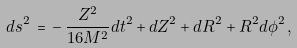Convert formula to latex. <formula><loc_0><loc_0><loc_500><loc_500>d s ^ { 2 } \, = \, - \, \frac { Z ^ { 2 } } { 1 6 M ^ { 2 } } d t ^ { 2 } + d Z ^ { 2 } + d R ^ { 2 } + R ^ { 2 } d \phi ^ { 2 } \, ,</formula> 